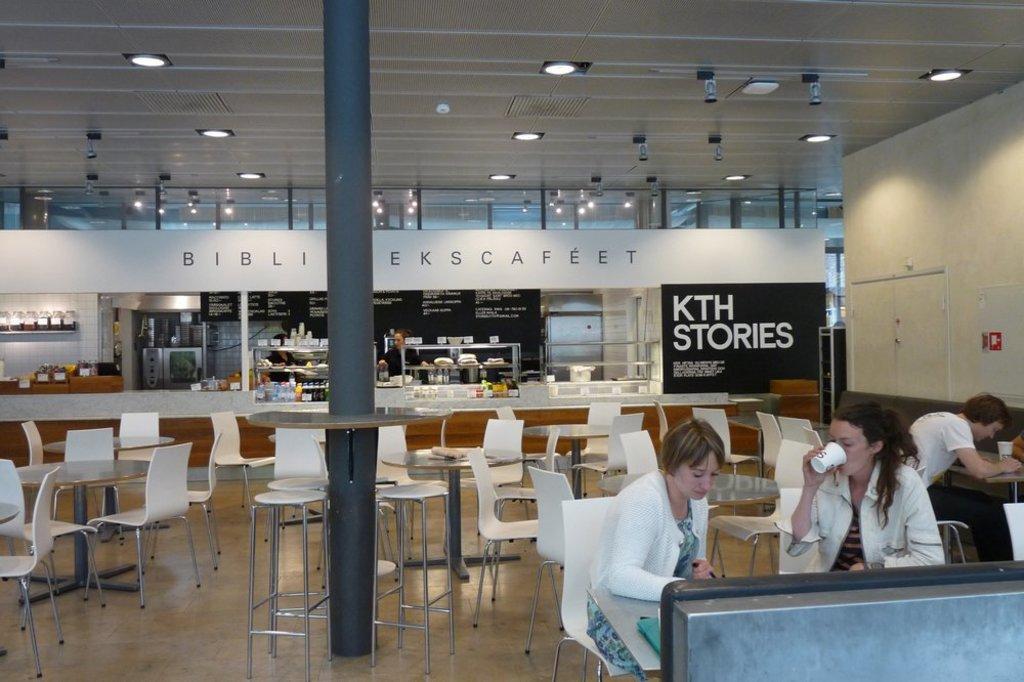Could you give a brief overview of what you see in this image? in this image the big room is there the floor contains chair,table,bottles and some posters are there in the room some of people they are sitting on chair and doing something. 